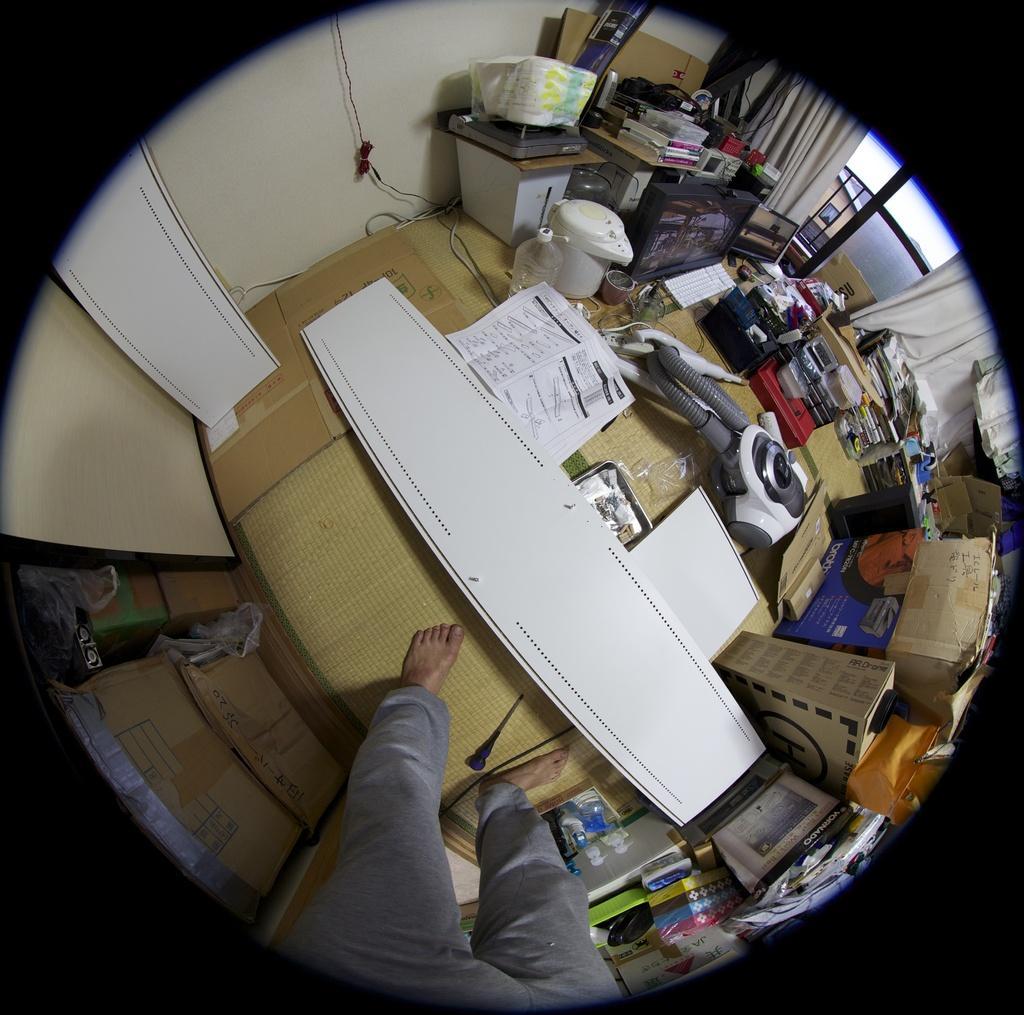Please provide a concise description of this image. This is an aerial view and here we can see a person, table, papers, stands, books, boxes, bottles, curtains, covers, card boards, a can and some other objects. 